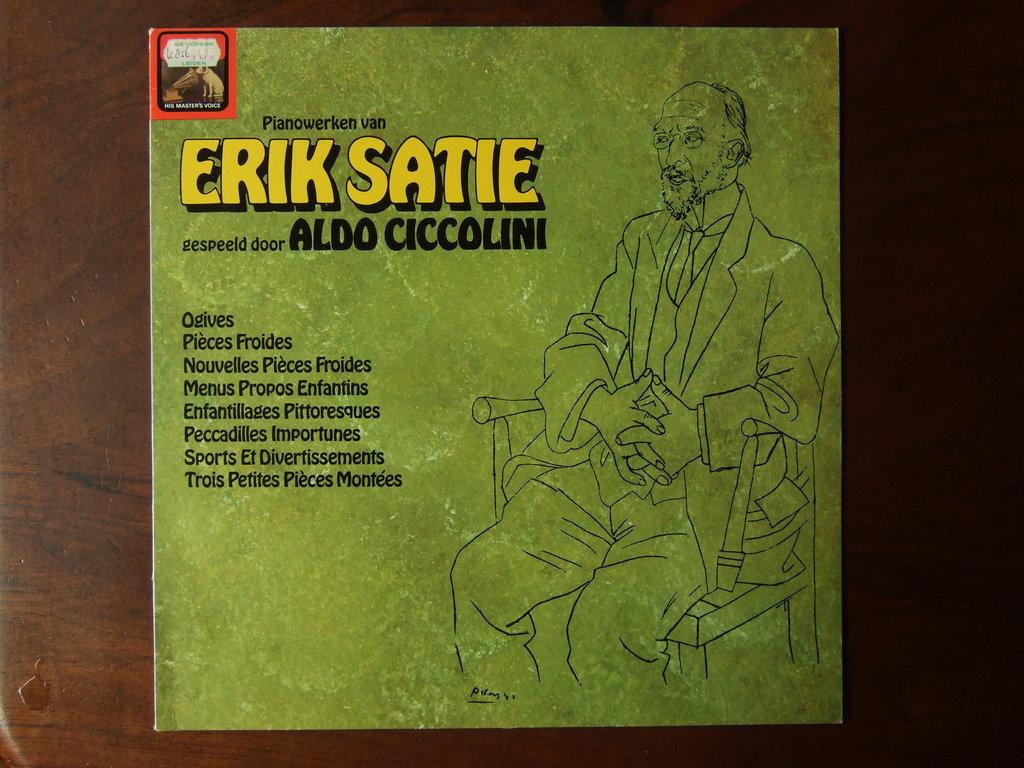Who is the artist?
Provide a succinct answer. Erik satie. What do the big yellow words say?
Ensure brevity in your answer.  Erik satie. 